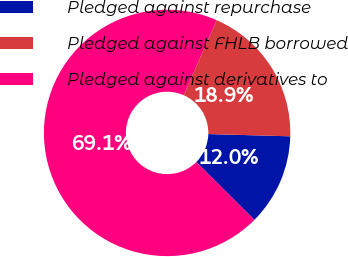Convert chart. <chart><loc_0><loc_0><loc_500><loc_500><pie_chart><fcel>Pledged against repurchase<fcel>Pledged against FHLB borrowed<fcel>Pledged against derivatives to<nl><fcel>12.03%<fcel>18.86%<fcel>69.12%<nl></chart> 